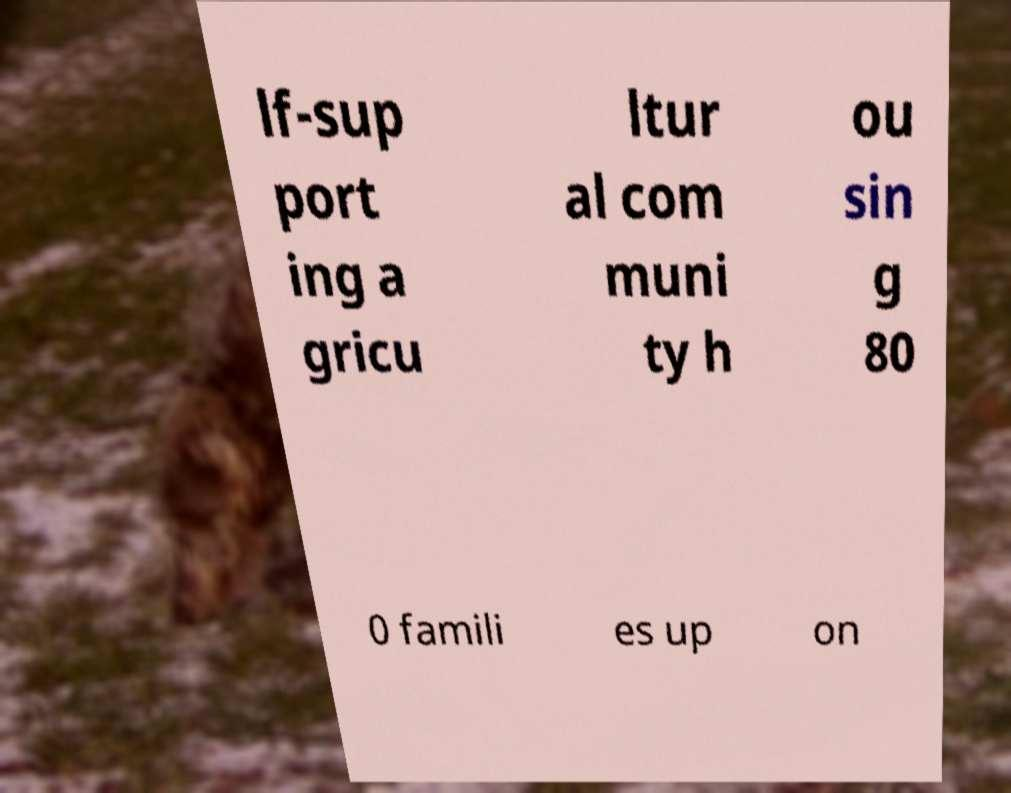Can you accurately transcribe the text from the provided image for me? lf-sup port ing a gricu ltur al com muni ty h ou sin g 80 0 famili es up on 